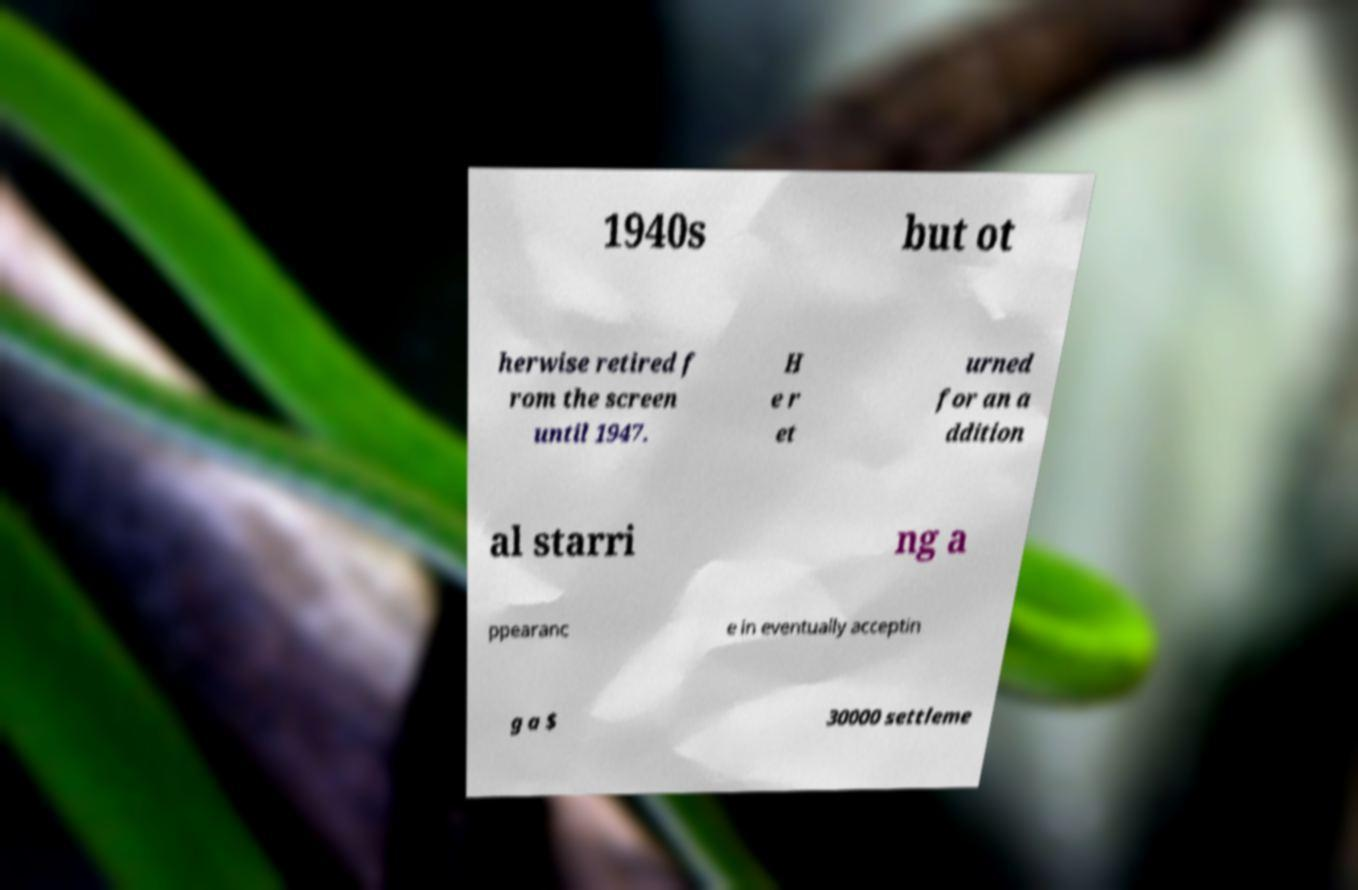Could you assist in decoding the text presented in this image and type it out clearly? 1940s but ot herwise retired f rom the screen until 1947. H e r et urned for an a ddition al starri ng a ppearanc e in eventually acceptin g a $ 30000 settleme 